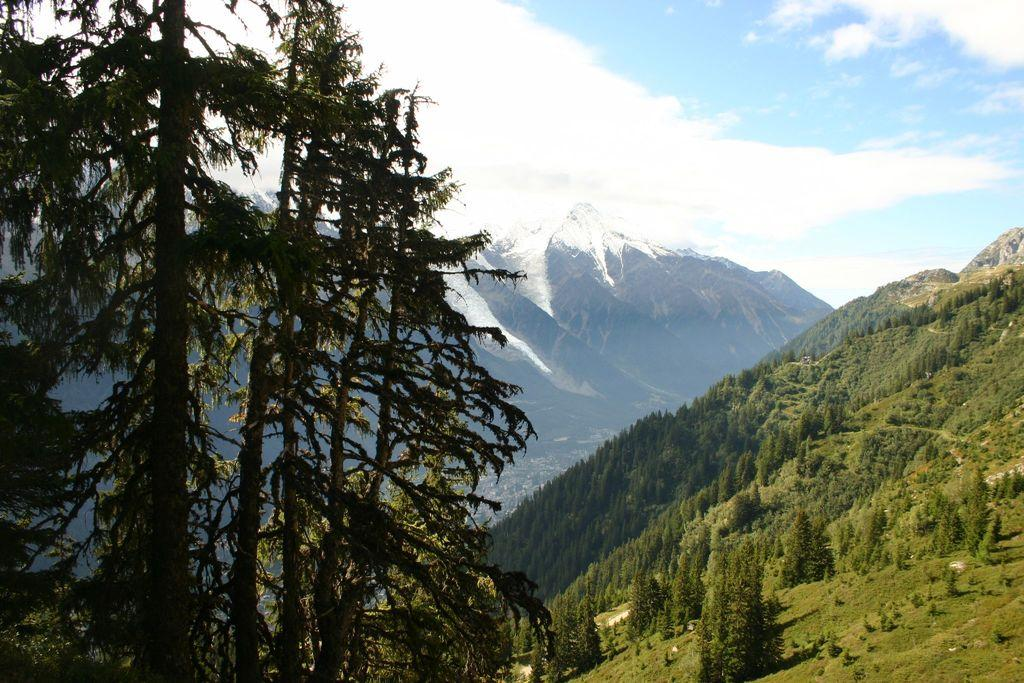What type of vegetation can be seen in the image? There are trees in the image. What geographical features are present in the image? There are hills in the image. How many parcels are being delivered in the image? There are no parcels or delivery-related elements present in the image. What is the mass of the earth as depicted in the image? The image does not depict the earth or provide any information about its mass. 